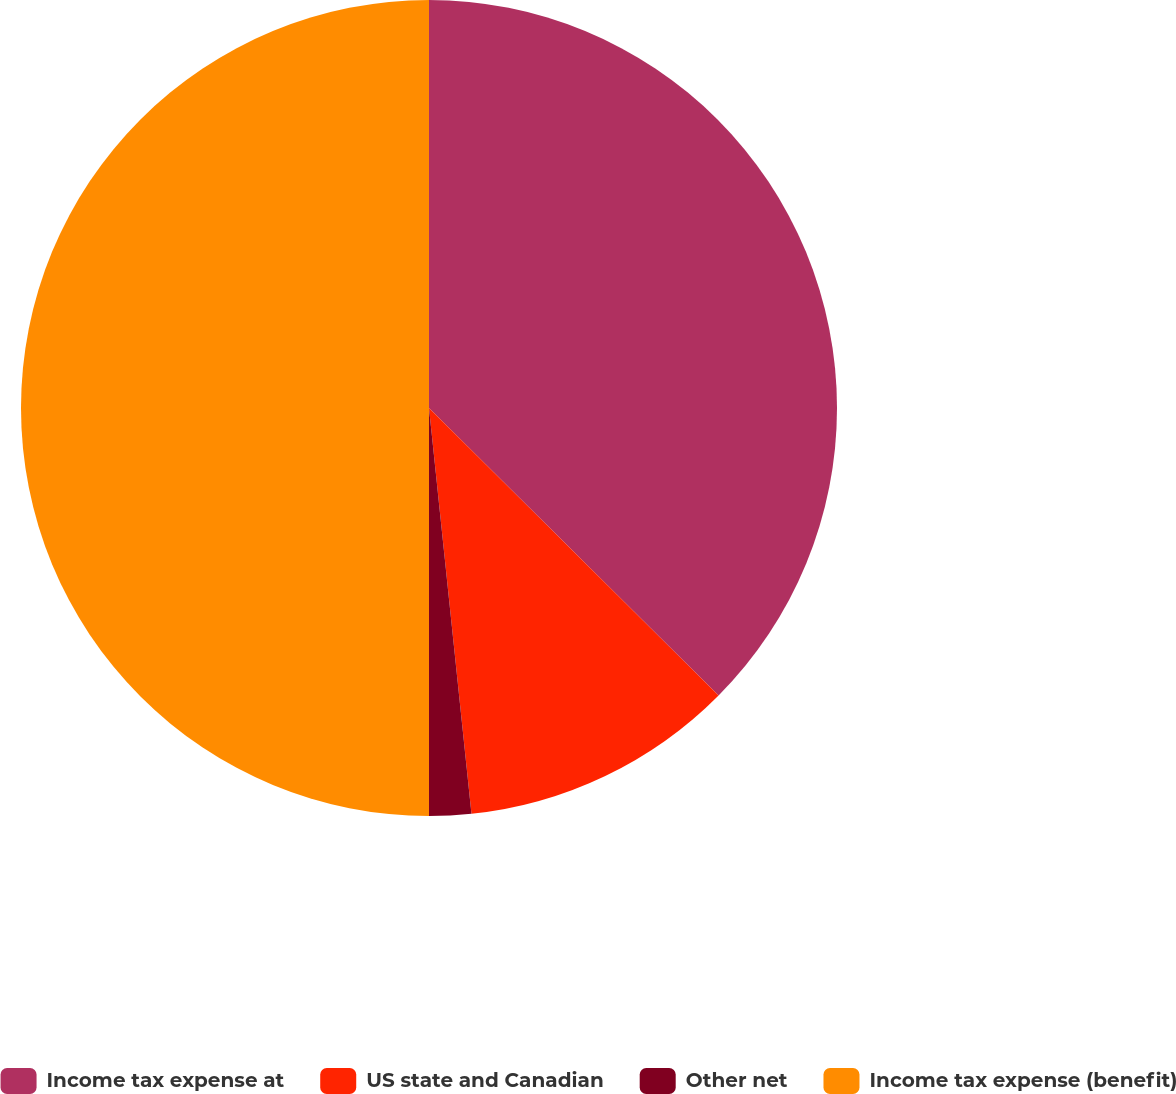Convert chart to OTSL. <chart><loc_0><loc_0><loc_500><loc_500><pie_chart><fcel>Income tax expense at<fcel>US state and Canadian<fcel>Other net<fcel>Income tax expense (benefit)<nl><fcel>37.44%<fcel>10.9%<fcel>1.66%<fcel>50.0%<nl></chart> 